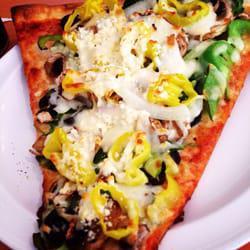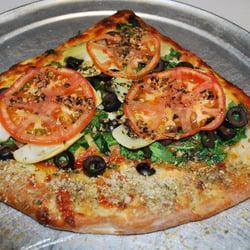The first image is the image on the left, the second image is the image on the right. Evaluate the accuracy of this statement regarding the images: "A wedge-shaped slice is missing from a deep-dish round 'pie' in one image.". Is it true? Answer yes or no. No. The first image is the image on the left, the second image is the image on the right. Evaluate the accuracy of this statement regarding the images: "In one of the images a piece of pizza pie is missing.". Is it true? Answer yes or no. No. 